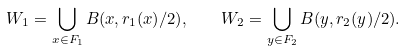Convert formula to latex. <formula><loc_0><loc_0><loc_500><loc_500>W _ { 1 } = \bigcup _ { x \in F _ { 1 } } B ( x , r _ { 1 } ( x ) / 2 ) , \quad W _ { 2 } = \bigcup _ { y \in F _ { 2 } } B ( y , r _ { 2 } ( y ) / 2 ) .</formula> 